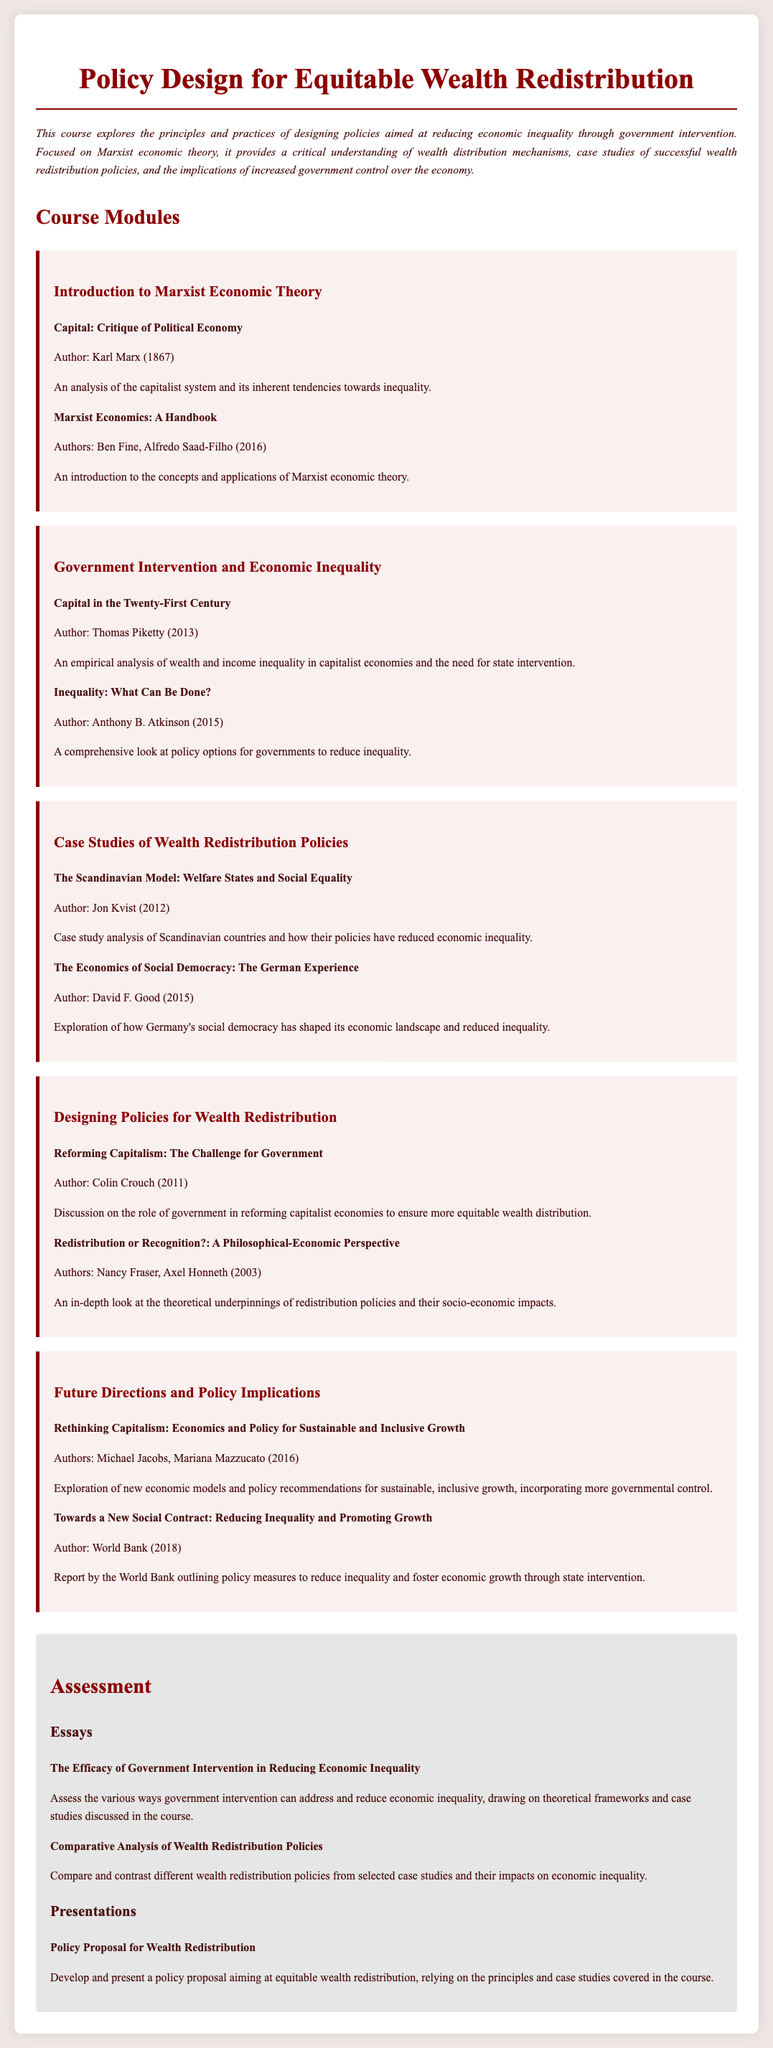what is the title of the course? The title of the course is mentioned at the top of the document.
Answer: Policy Design for Equitable Wealth Redistribution who is the author of "Capital: Critique of Political Economy"? The author is credited at the end of the title in the reading section.
Answer: Karl Marx what is the focus of the course? The focus is summarized in the description at the beginning of the document.
Answer: designing policies aimed at reducing economic inequality how many modules are in the syllabus? The number of modules is indicated by the headings in the document.
Answer: Five name one case study mentioned in the syllabus. The case studies are listed in the section dedicated to them, and any one of them can be cited.
Answer: The Scandinavian Model: Welfare States and Social Equality what year was "Capital in the Twenty-First Century" published? The publication year is provided alongside the title of the reading.
Answer: 2013 what is the main assessment type mentioned in the syllabus? The assessment types are laid out in the assessment section of the document.
Answer: Essays who are the authors of the reading "Redistribution or Recognition?" The authors are listed after the title in the reading section.
Answer: Nancy Fraser, Axel Honneth what is the main theme of the last module? The last module's title describes its main theme, which can be inferred from it.
Answer: Future Directions and Policy Implications 